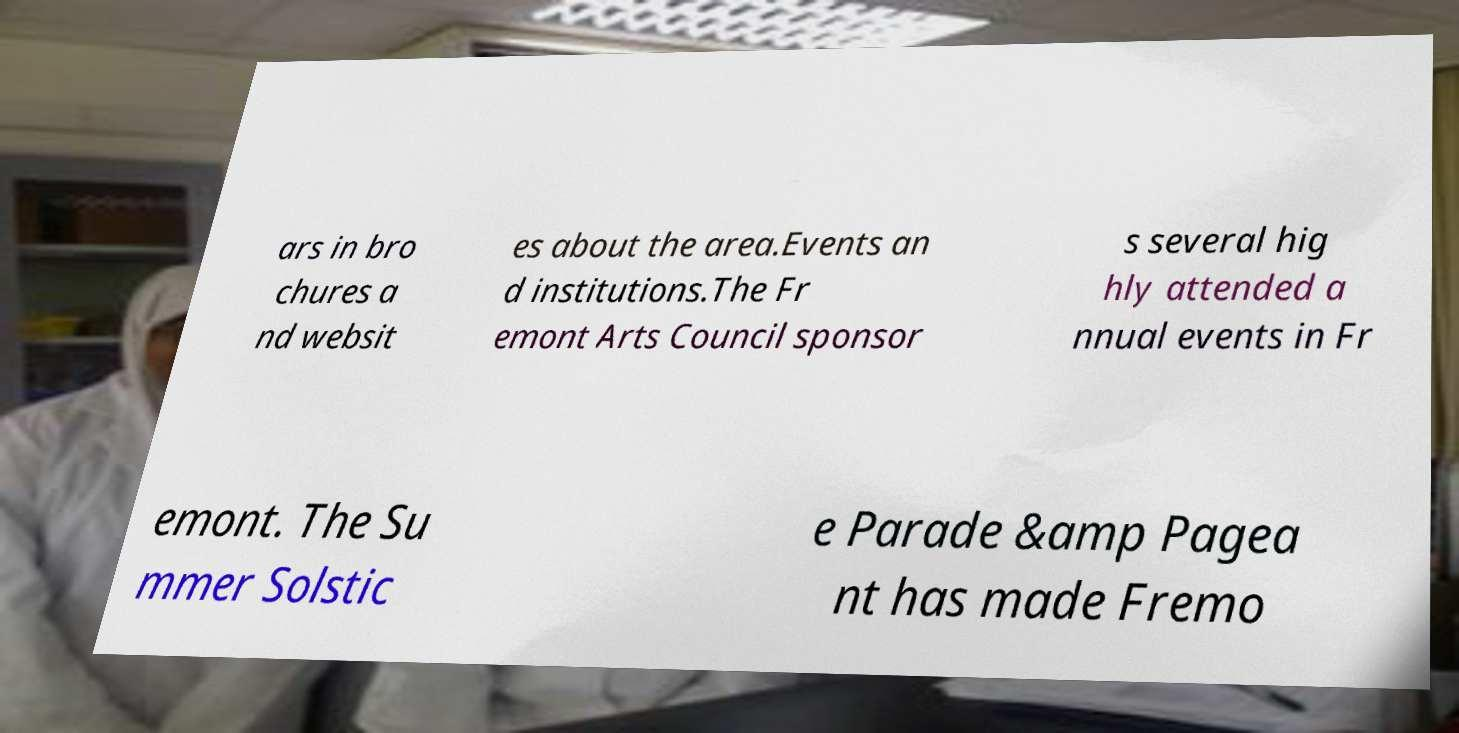Please identify and transcribe the text found in this image. ars in bro chures a nd websit es about the area.Events an d institutions.The Fr emont Arts Council sponsor s several hig hly attended a nnual events in Fr emont. The Su mmer Solstic e Parade &amp Pagea nt has made Fremo 